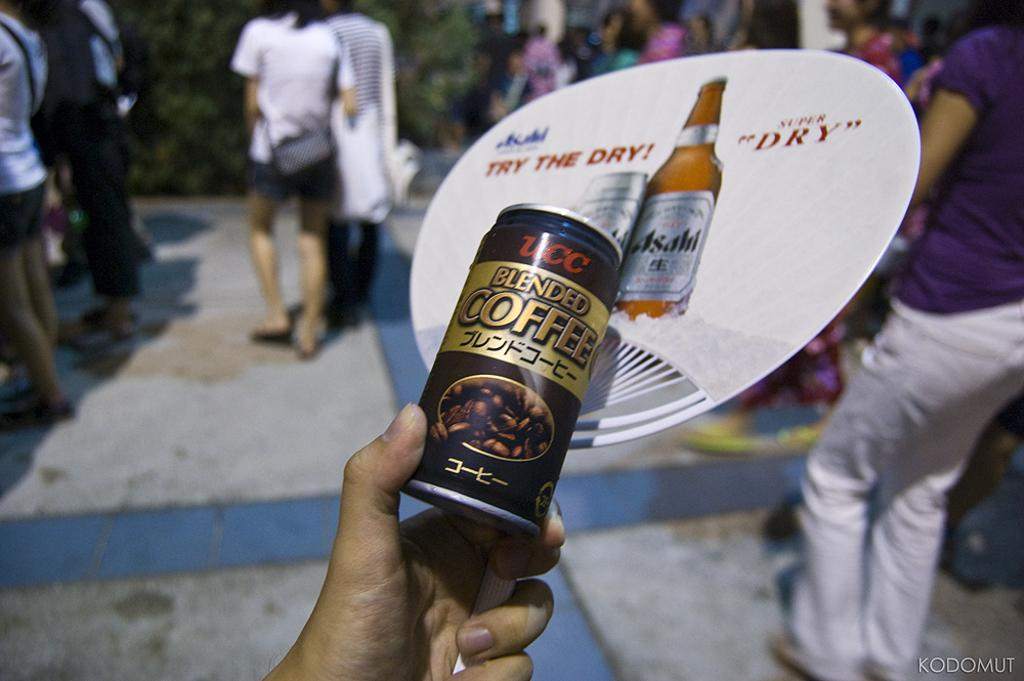Who is the main subject in the image? There is a man in the image. What is the man holding in his hand? The man is holding a coffee tin in his hand. Can you describe the background of the image? There are people standing in the background of the image. What type of music is being played in the background of the image? There is no indication of music being played in the image. 